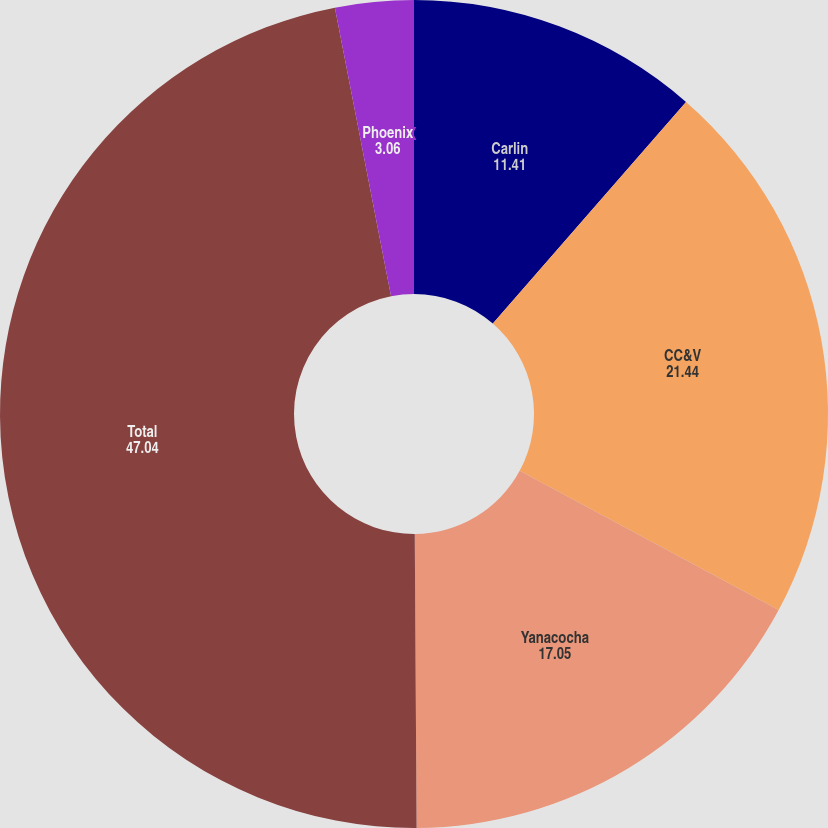Convert chart to OTSL. <chart><loc_0><loc_0><loc_500><loc_500><pie_chart><fcel>Carlin<fcel>CC&V<fcel>Yanacocha<fcel>Total<fcel>Phoenix<nl><fcel>11.41%<fcel>21.44%<fcel>17.05%<fcel>47.04%<fcel>3.06%<nl></chart> 